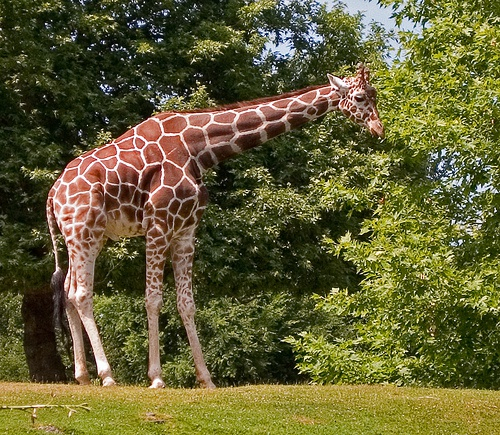Describe the objects in this image and their specific colors. I can see a giraffe in darkgreen, brown, maroon, black, and white tones in this image. 